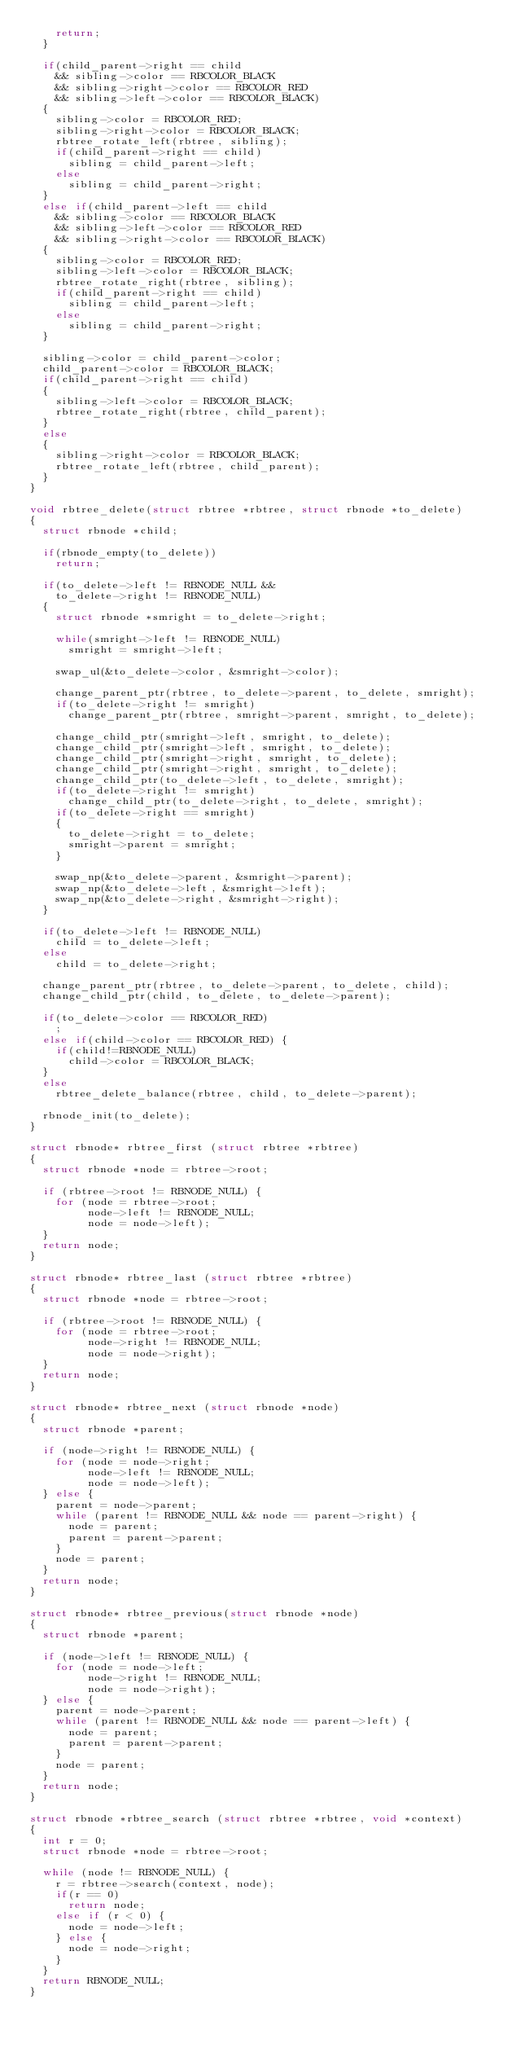<code> <loc_0><loc_0><loc_500><loc_500><_C_>		return;
	}

	if(child_parent->right == child
		&& sibling->color == RBCOLOR_BLACK
		&& sibling->right->color == RBCOLOR_RED
		&& sibling->left->color == RBCOLOR_BLACK)
	{
		sibling->color = RBCOLOR_RED;
		sibling->right->color = RBCOLOR_BLACK;
		rbtree_rotate_left(rbtree, sibling);
		if(child_parent->right == child)
			sibling = child_parent->left;
		else
			sibling = child_parent->right;
	}
	else if(child_parent->left == child
		&& sibling->color == RBCOLOR_BLACK
		&& sibling->left->color == RBCOLOR_RED
		&& sibling->right->color == RBCOLOR_BLACK)
	{
		sibling->color = RBCOLOR_RED;
		sibling->left->color = RBCOLOR_BLACK;
		rbtree_rotate_right(rbtree, sibling);
		if(child_parent->right == child)
			sibling = child_parent->left;
		else
			sibling = child_parent->right;
	}

	sibling->color = child_parent->color;
	child_parent->color = RBCOLOR_BLACK;
	if(child_parent->right == child)
	{
		sibling->left->color = RBCOLOR_BLACK;
		rbtree_rotate_right(rbtree, child_parent);
	}
	else
	{
		sibling->right->color = RBCOLOR_BLACK;
		rbtree_rotate_left(rbtree, child_parent);
	}
}

void rbtree_delete(struct rbtree *rbtree, struct rbnode *to_delete)
{
	struct rbnode *child;

	if(rbnode_empty(to_delete))
		return;

	if(to_delete->left != RBNODE_NULL &&
		to_delete->right != RBNODE_NULL)
	{
		struct rbnode *smright = to_delete->right;

		while(smright->left != RBNODE_NULL)
			smright = smright->left;

		swap_ul(&to_delete->color, &smright->color);

		change_parent_ptr(rbtree, to_delete->parent, to_delete, smright);
		if(to_delete->right != smright)
			change_parent_ptr(rbtree, smright->parent, smright, to_delete);

		change_child_ptr(smright->left, smright, to_delete);
		change_child_ptr(smright->left, smright, to_delete);
		change_child_ptr(smright->right, smright, to_delete);
		change_child_ptr(smright->right, smright, to_delete);
		change_child_ptr(to_delete->left, to_delete, smright);
		if(to_delete->right != smright)
			change_child_ptr(to_delete->right, to_delete, smright);
		if(to_delete->right == smright)
		{
			to_delete->right = to_delete;
			smright->parent = smright;
		}

		swap_np(&to_delete->parent, &smright->parent);
		swap_np(&to_delete->left, &smright->left);
		swap_np(&to_delete->right, &smright->right);
	}

	if(to_delete->left != RBNODE_NULL)
		child = to_delete->left;
	else
		child = to_delete->right;

	change_parent_ptr(rbtree, to_delete->parent, to_delete, child);
	change_child_ptr(child, to_delete, to_delete->parent);

	if(to_delete->color == RBCOLOR_RED)
		;
	else if(child->color == RBCOLOR_RED) {
		if(child!=RBNODE_NULL)
			child->color = RBCOLOR_BLACK;
	}
	else
		rbtree_delete_balance(rbtree, child, to_delete->parent);

	rbnode_init(to_delete);
}

struct rbnode* rbtree_first (struct rbtree *rbtree)
{
	struct rbnode *node = rbtree->root;

	if (rbtree->root != RBNODE_NULL) {
		for (node = rbtree->root;
		     node->left != RBNODE_NULL;
		     node = node->left);
	}
	return node;
}

struct rbnode* rbtree_last (struct rbtree *rbtree)
{
	struct rbnode *node = rbtree->root;

	if (rbtree->root != RBNODE_NULL) {
		for (node = rbtree->root;
		     node->right != RBNODE_NULL;
		     node = node->right);
	}
	return node;
}

struct rbnode* rbtree_next (struct rbnode *node)
{
	struct rbnode *parent;

	if (node->right != RBNODE_NULL) {
		for (node = node->right;
		     node->left != RBNODE_NULL;
		     node = node->left);
	} else {
		parent = node->parent;
		while (parent != RBNODE_NULL && node == parent->right) {
			node = parent;
			parent = parent->parent;
		}
		node = parent;
	}
	return node;
}

struct rbnode* rbtree_previous(struct rbnode *node)
{
	struct rbnode *parent;

	if (node->left != RBNODE_NULL) {
		for (node = node->left;
		     node->right != RBNODE_NULL;
		     node = node->right);
	} else {
		parent = node->parent;
		while (parent != RBNODE_NULL && node == parent->left) {
			node = parent;
			parent = parent->parent;
		}
		node = parent;
	}
	return node;
}

struct rbnode *rbtree_search (struct rbtree *rbtree, void *context)
{
	int r = 0;
	struct rbnode *node = rbtree->root;

	while (node != RBNODE_NULL) {
		r = rbtree->search(context, node);
		if(r == 0)
			return node;
		else if (r < 0) {
			node = node->left;
		} else {
			node = node->right;
		}
	}
	return RBNODE_NULL;
}
</code> 